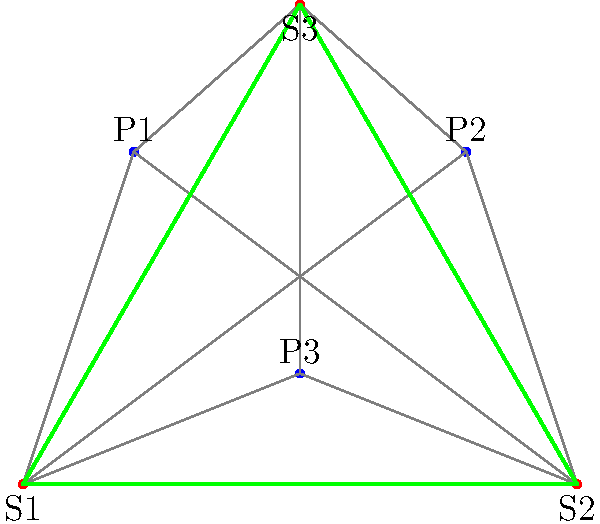In the network topology shown, which server placement would minimize latency for a Go game server, assuming equal player distribution and that latency is proportional to distance? To determine the optimal server placement for minimizing latency, we need to consider the following steps:

1. Understand the network topology:
   - We have three potential server locations (S1, S2, S3) forming a triangle.
   - There are three players (P1, P2, P3) distributed across the network.

2. Assume latency is proportional to distance:
   - The shorter the distance between a player and a server, the lower the latency.

3. Consider equal player distribution:
   - All players should have similar importance in the decision.

4. Analyze each server location:
   - S1: Closest to P1, but far from P2 and P3.
   - S2: Closest to P2, but far from P1 and P3.
   - S3: Relatively central, providing a balanced distance to all players.

5. Apply the concept of network centrality:
   - In network theory, the node with the highest centrality often provides the best overall connectivity.
   - S3 appears to have the highest centrality in this topology.

6. Consider the impact on Go game server performance:
   - Lower latency leads to smoother gameplay and fewer synchronization issues.
   - A central server location would provide more consistent latency across all players.

7. Conclude based on the analysis:
   - S3 provides the most balanced distances to all players.
   - It minimizes the maximum latency any single player would experience.
   - This placement would offer the most equitable gaming experience for all players.

Therefore, the server placement that would minimize latency for a Go game server in this network topology is S3.
Answer: S3 